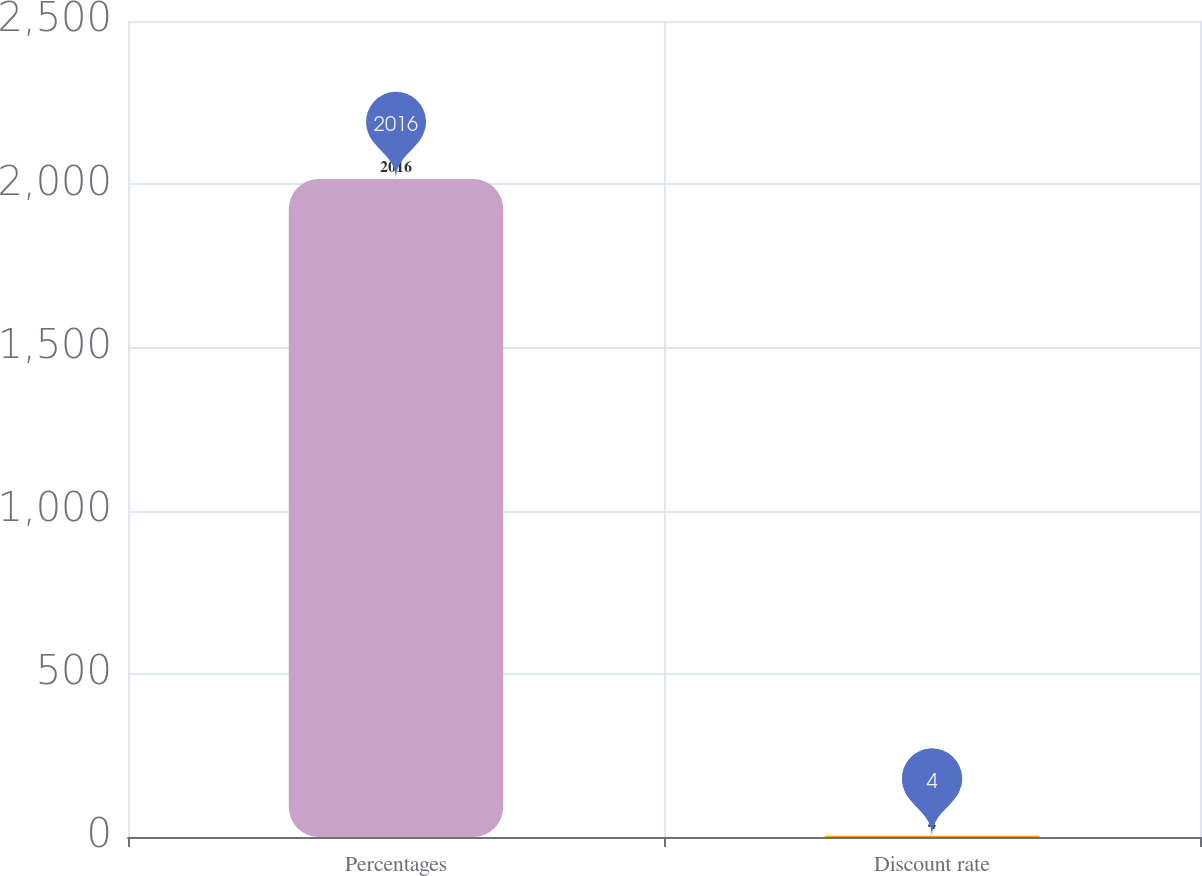Convert chart to OTSL. <chart><loc_0><loc_0><loc_500><loc_500><bar_chart><fcel>Percentages<fcel>Discount rate<nl><fcel>2016<fcel>4<nl></chart> 